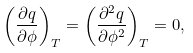Convert formula to latex. <formula><loc_0><loc_0><loc_500><loc_500>\left ( { \frac { \partial q } { \partial \phi } } \right ) _ { T } = \left ( { \frac { \partial ^ { 2 } q } { \partial \phi ^ { 2 } } } \right ) _ { T } = 0 ,</formula> 